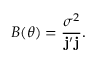<formula> <loc_0><loc_0><loc_500><loc_500>B ( \theta ) = \frac { \sigma ^ { 2 } } { j ^ { \prime } j } .</formula> 